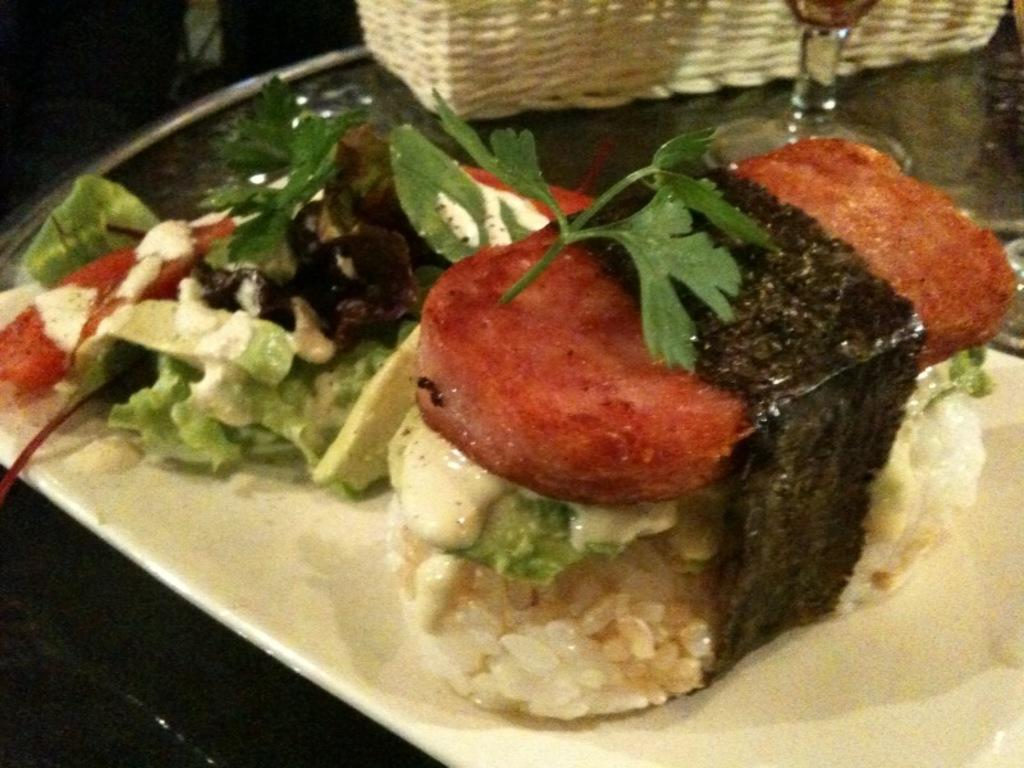What is contained in the tray that is visible in the image? There are food items in a tray in the image. What type of container is present in the image? There is a glass in the image. What type of container is also present in the image? There is a basket in the image. What is the color or appearance of the surface on which the objects are placed? There are other objects on a dark surface in the image. What type of apparel is the pig wearing in the image? There is no pig present in the image, and therefore no apparel can be observed. 